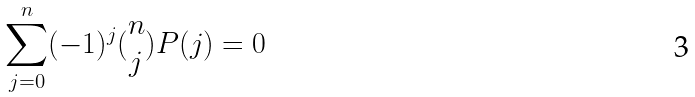<formula> <loc_0><loc_0><loc_500><loc_500>\sum _ { j = 0 } ^ { n } ( - 1 ) ^ { j } ( \begin{matrix} n \\ j \end{matrix} ) P ( j ) = 0</formula> 